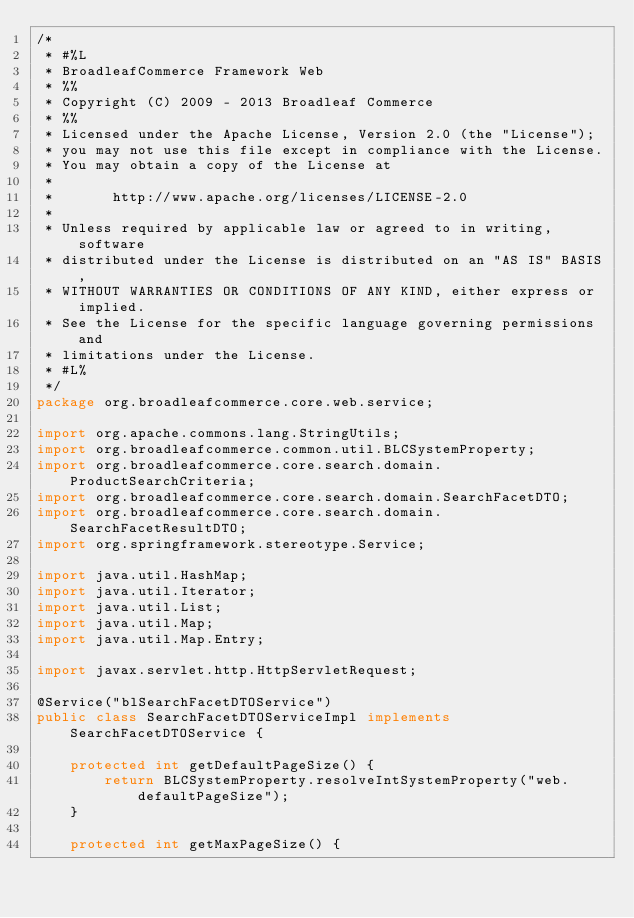<code> <loc_0><loc_0><loc_500><loc_500><_Java_>/*
 * #%L
 * BroadleafCommerce Framework Web
 * %%
 * Copyright (C) 2009 - 2013 Broadleaf Commerce
 * %%
 * Licensed under the Apache License, Version 2.0 (the "License");
 * you may not use this file except in compliance with the License.
 * You may obtain a copy of the License at
 * 
 *       http://www.apache.org/licenses/LICENSE-2.0
 * 
 * Unless required by applicable law or agreed to in writing, software
 * distributed under the License is distributed on an "AS IS" BASIS,
 * WITHOUT WARRANTIES OR CONDITIONS OF ANY KIND, either express or implied.
 * See the License for the specific language governing permissions and
 * limitations under the License.
 * #L%
 */
package org.broadleafcommerce.core.web.service;

import org.apache.commons.lang.StringUtils;
import org.broadleafcommerce.common.util.BLCSystemProperty;
import org.broadleafcommerce.core.search.domain.ProductSearchCriteria;
import org.broadleafcommerce.core.search.domain.SearchFacetDTO;
import org.broadleafcommerce.core.search.domain.SearchFacetResultDTO;
import org.springframework.stereotype.Service;

import java.util.HashMap;
import java.util.Iterator;
import java.util.List;
import java.util.Map;
import java.util.Map.Entry;

import javax.servlet.http.HttpServletRequest;

@Service("blSearchFacetDTOService")
public class SearchFacetDTOServiceImpl implements SearchFacetDTOService {
    
    protected int getDefaultPageSize() {
        return BLCSystemProperty.resolveIntSystemProperty("web.defaultPageSize");
    }

    protected int getMaxPageSize() {</code> 